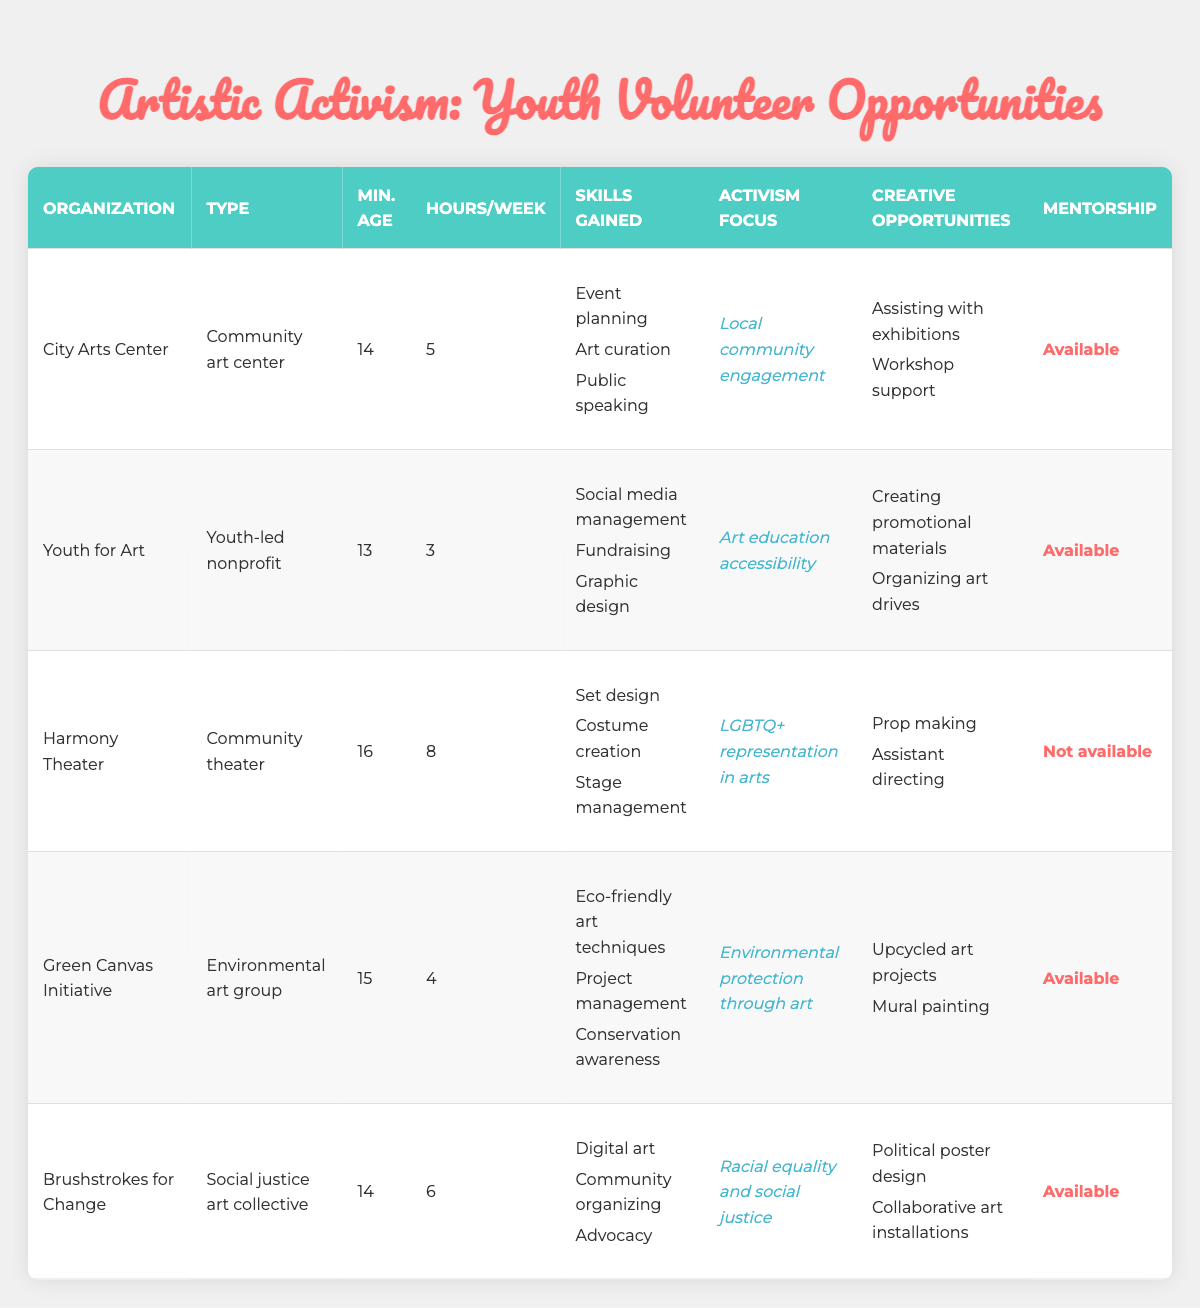What is the minimum age requirement for volunteering at the Youth for Art organization? The table states that the minimum age for Youth for Art is listed under the "Min. Age" column, which shows 13.
Answer: 13 How many hours per week does a volunteer generally work at the City Arts Center? According to the "Hours/Week" column for City Arts Center, it indicates that volunteers typically work 5 hours a week.
Answer: 5 Which organization focuses on LGBTQ+ representation in the arts? The "Activism Focus" column for Harmony Theater specifies that this organization focuses on LGBTQ+ representation in arts.
Answer: Harmony Theater How many total hours per week could a volunteer gain if they participated in both the Green Canvas Initiative and Brushstrokes for Change? The table shows that Green Canvas Initiative requires 4 hours and Brushstrokes for Change requires 6 hours. Adding these together, 4 + 6 equals 10 hours per week in total.
Answer: 10 Which organizations provide mentorship to their volunteers? Checking the "Mentorship" column, City Arts Center, Youth for Art, Green Canvas Initiative, and Brushstrokes for Change all have mentorship available, while Harmony Theater does not.
Answer: City Arts Center, Youth for Art, Green Canvas Initiative, Brushstrokes for Change What skills can a volunteer gain from working at the Harmony Theater? The "Skills Gained" column indicates that volunteers can learn Set design, Costume creation, and Stage management at Harmony Theater.
Answer: Set design, Costume creation, Stage management Is it true that all organizations listed have a minimum age requirement of 14 or younger? Examining the "Min. Age" column reveals that both Youth for Art (age 13) and Green Canvas Initiative (age 15) have a minimum age requirement of less than or equal to 14. However, Harmony Theater requires a minimum age of 16, making this statement false.
Answer: No What is the average number of hours per week required for the organizations? The hours per week for organizations are 5, 3, 8, 4, and 6. To find the average, we first calculate the total hours: 5 + 3 + 8 + 4 + 6 = 26. Then divide by the number of organizations, which is 5: 26 / 5 = 5.2 hours per week is the average.
Answer: 5.2 